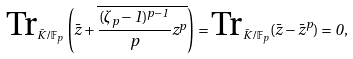<formula> <loc_0><loc_0><loc_500><loc_500>\text {Tr} _ { \bar { K } / { \mathbb { F } } _ { p } } \left ( \bar { z } + \overline { \frac { ( \zeta _ { p } - 1 ) ^ { p - 1 } } p z ^ { p } } \right ) = \text {Tr} _ { \bar { K } / { \mathbb { F } } _ { p } } ( \bar { z } - \bar { z } ^ { p } ) = 0 ,</formula> 